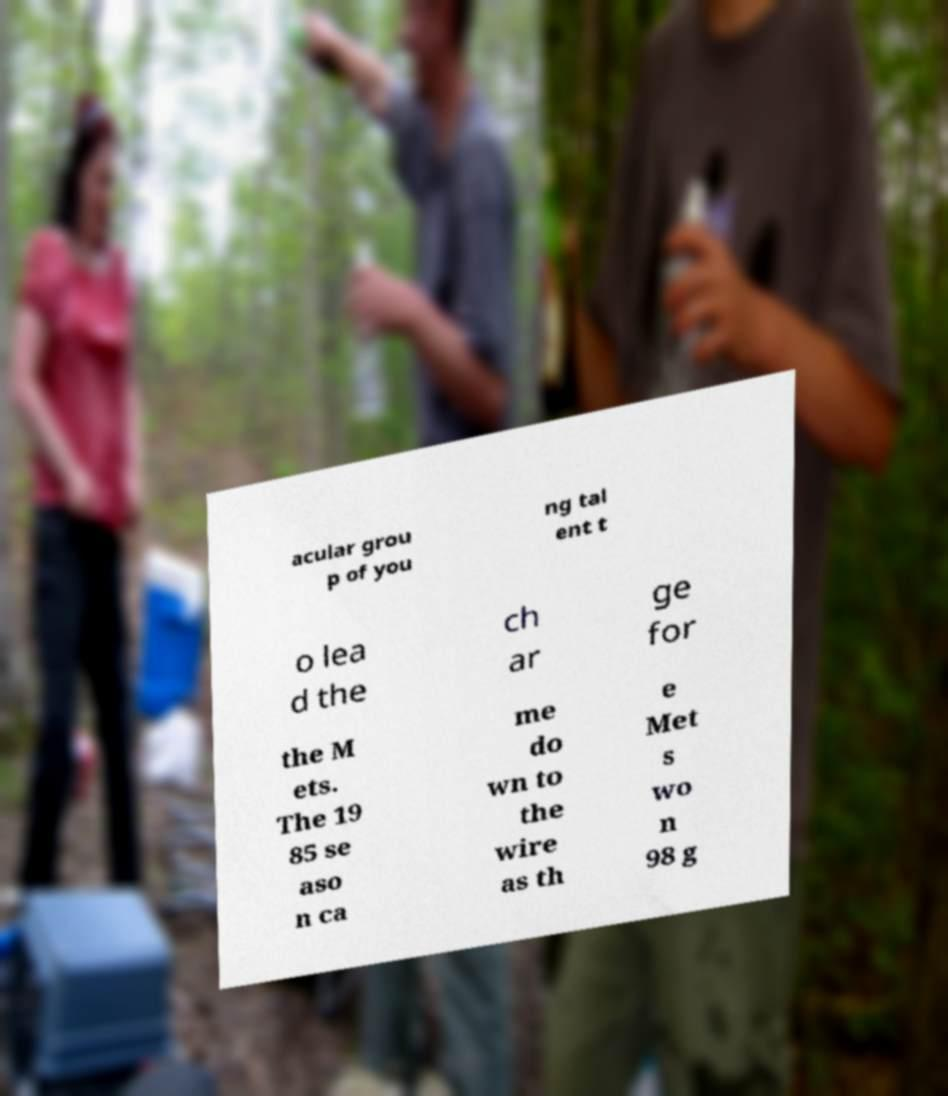Please read and relay the text visible in this image. What does it say? acular grou p of you ng tal ent t o lea d the ch ar ge for the M ets. The 19 85 se aso n ca me do wn to the wire as th e Met s wo n 98 g 